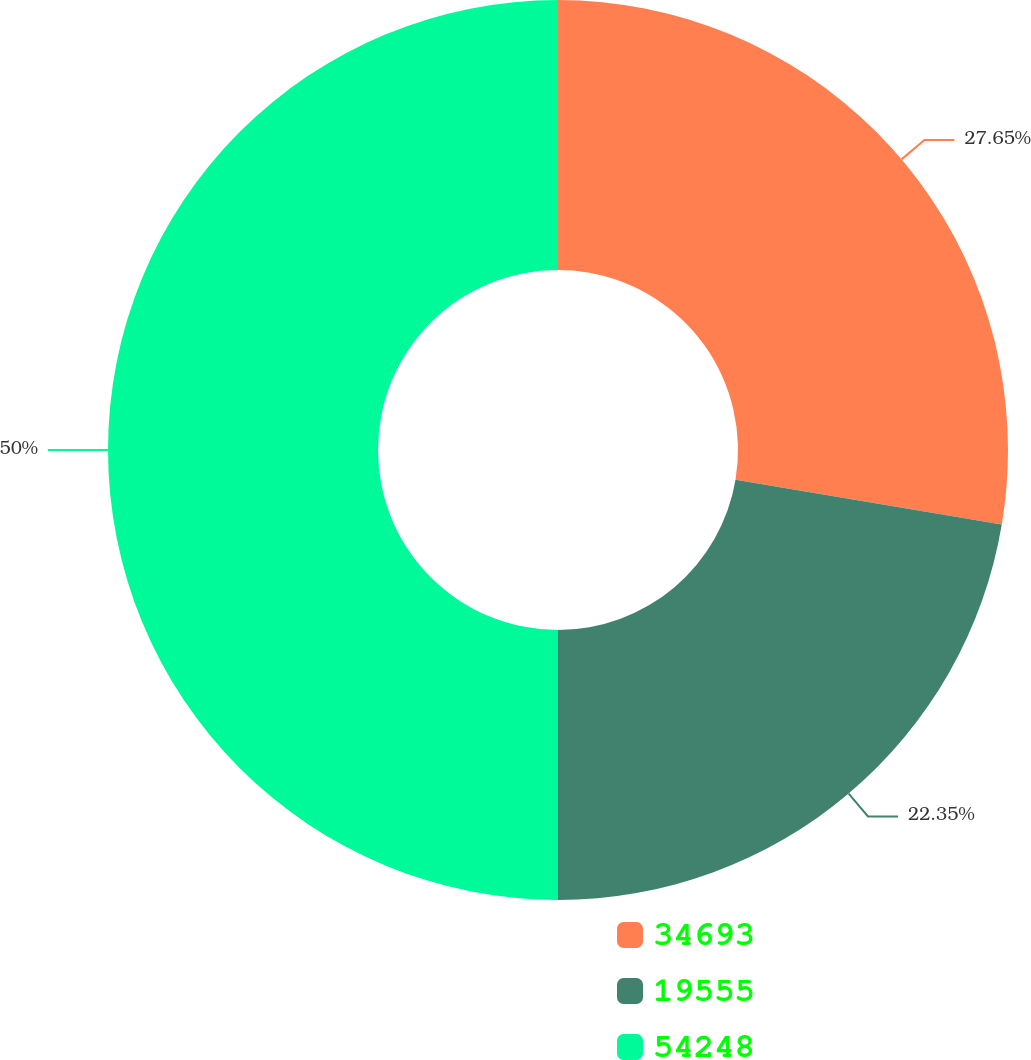<chart> <loc_0><loc_0><loc_500><loc_500><pie_chart><fcel>34693<fcel>19555<fcel>54248<nl><fcel>27.65%<fcel>22.35%<fcel>50.0%<nl></chart> 